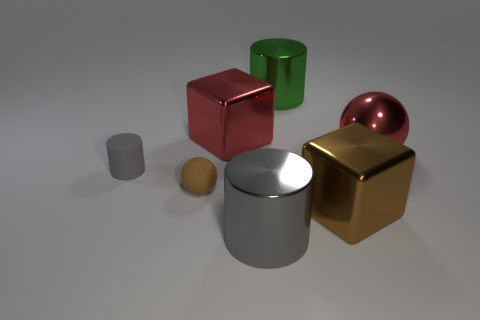What shape is the big green object that is made of the same material as the large red cube?
Give a very brief answer. Cylinder. There is a gray cylinder on the right side of the small ball; what is its size?
Give a very brief answer. Large. Are there the same number of tiny cylinders that are behind the large green metal thing and red shiny objects that are on the left side of the small brown sphere?
Your answer should be very brief. Yes. What color is the big metallic cylinder that is on the left side of the large shiny cylinder behind the metallic cube behind the small brown rubber object?
Offer a very short reply. Gray. What number of metallic cylinders are in front of the large brown block and behind the large brown metallic cube?
Give a very brief answer. 0. There is a big block in front of the rubber sphere; does it have the same color as the matte thing that is to the left of the brown matte sphere?
Make the answer very short. No. Is there anything else that is the same material as the big green cylinder?
Give a very brief answer. Yes. There is another matte object that is the same shape as the big green object; what is its size?
Ensure brevity in your answer.  Small. There is a big green shiny object; are there any shiny spheres behind it?
Your answer should be compact. No. Are there an equal number of things behind the red ball and small brown objects?
Keep it short and to the point. No. 